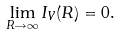<formula> <loc_0><loc_0><loc_500><loc_500>\lim _ { R \rightarrow \infty } I _ { V } ( R ) = 0 .</formula> 